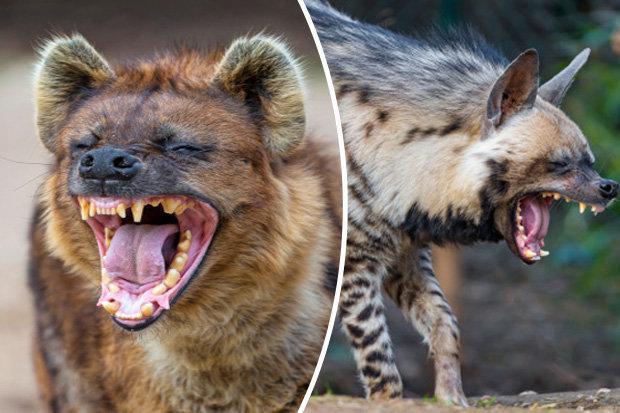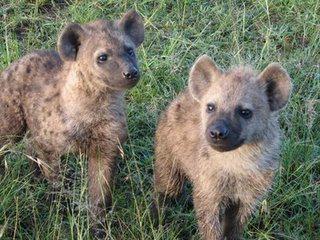The first image is the image on the left, the second image is the image on the right. For the images displayed, is the sentence "The images contain a total of one open-mouthed hyena baring fangs." factually correct? Answer yes or no. No. 